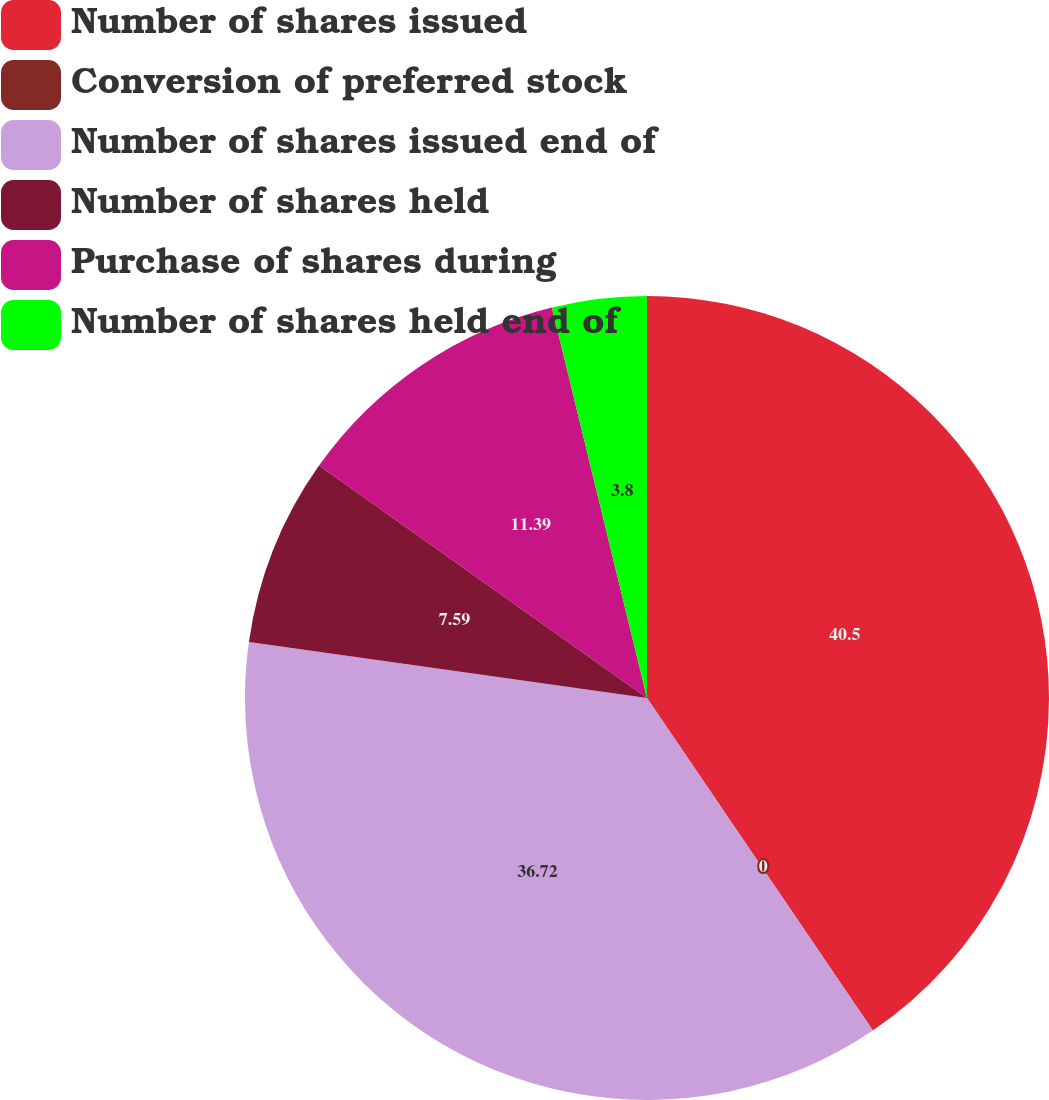<chart> <loc_0><loc_0><loc_500><loc_500><pie_chart><fcel>Number of shares issued<fcel>Conversion of preferred stock<fcel>Number of shares issued end of<fcel>Number of shares held<fcel>Purchase of shares during<fcel>Number of shares held end of<nl><fcel>40.51%<fcel>0.0%<fcel>36.72%<fcel>7.59%<fcel>11.39%<fcel>3.8%<nl></chart> 